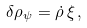<formula> <loc_0><loc_0><loc_500><loc_500>\delta \rho _ { \psi } = \dot { \rho } \, \xi \, ,</formula> 